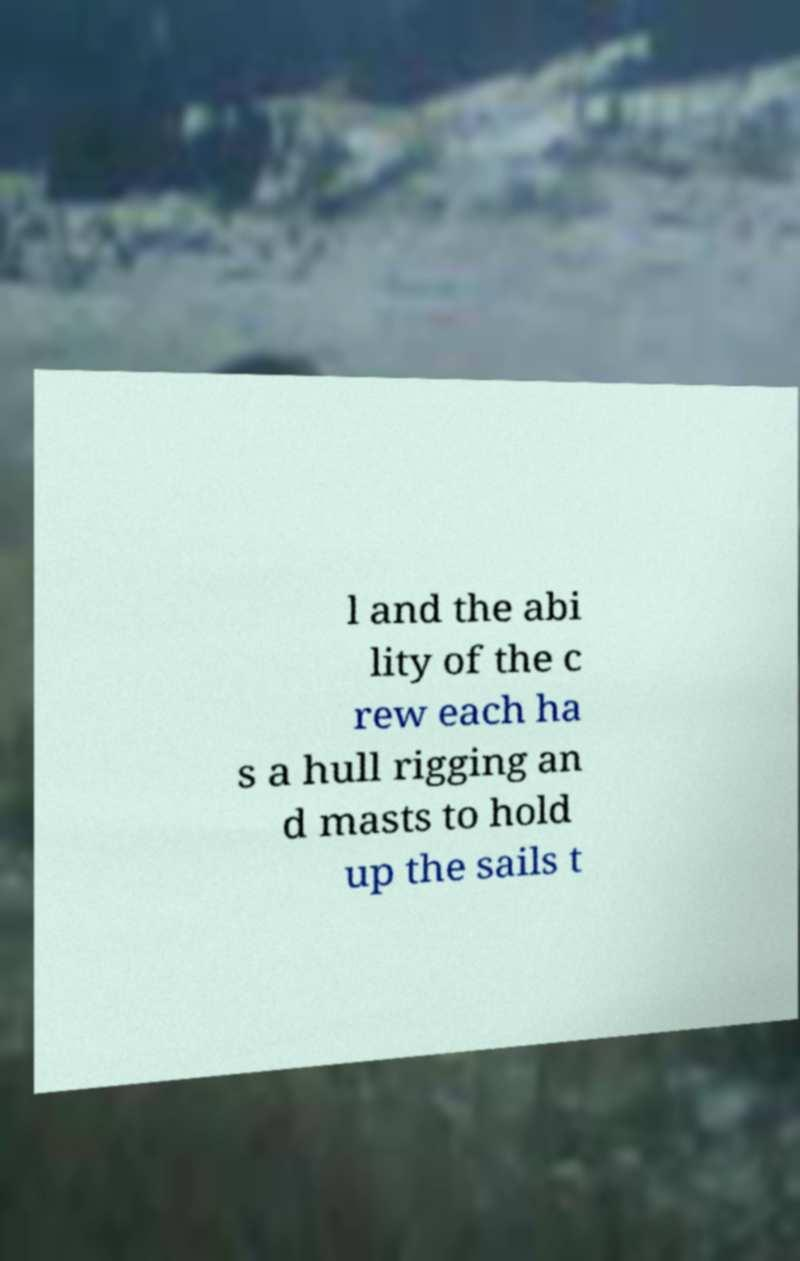Please identify and transcribe the text found in this image. l and the abi lity of the c rew each ha s a hull rigging an d masts to hold up the sails t 